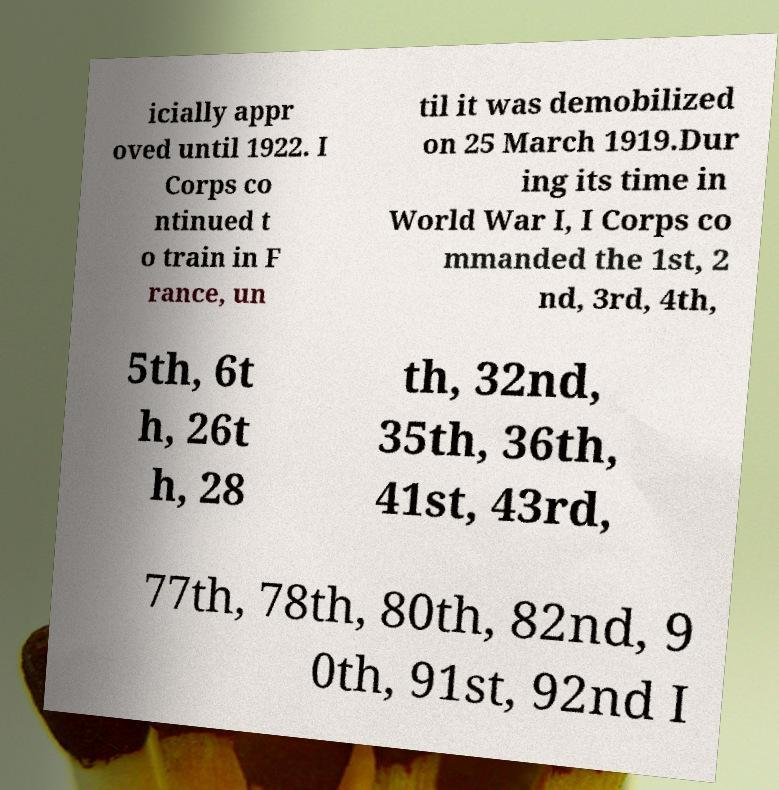Please read and relay the text visible in this image. What does it say? icially appr oved until 1922. I Corps co ntinued t o train in F rance, un til it was demobilized on 25 March 1919.Dur ing its time in World War I, I Corps co mmanded the 1st, 2 nd, 3rd, 4th, 5th, 6t h, 26t h, 28 th, 32nd, 35th, 36th, 41st, 43rd, 77th, 78th, 80th, 82nd, 9 0th, 91st, 92nd I 